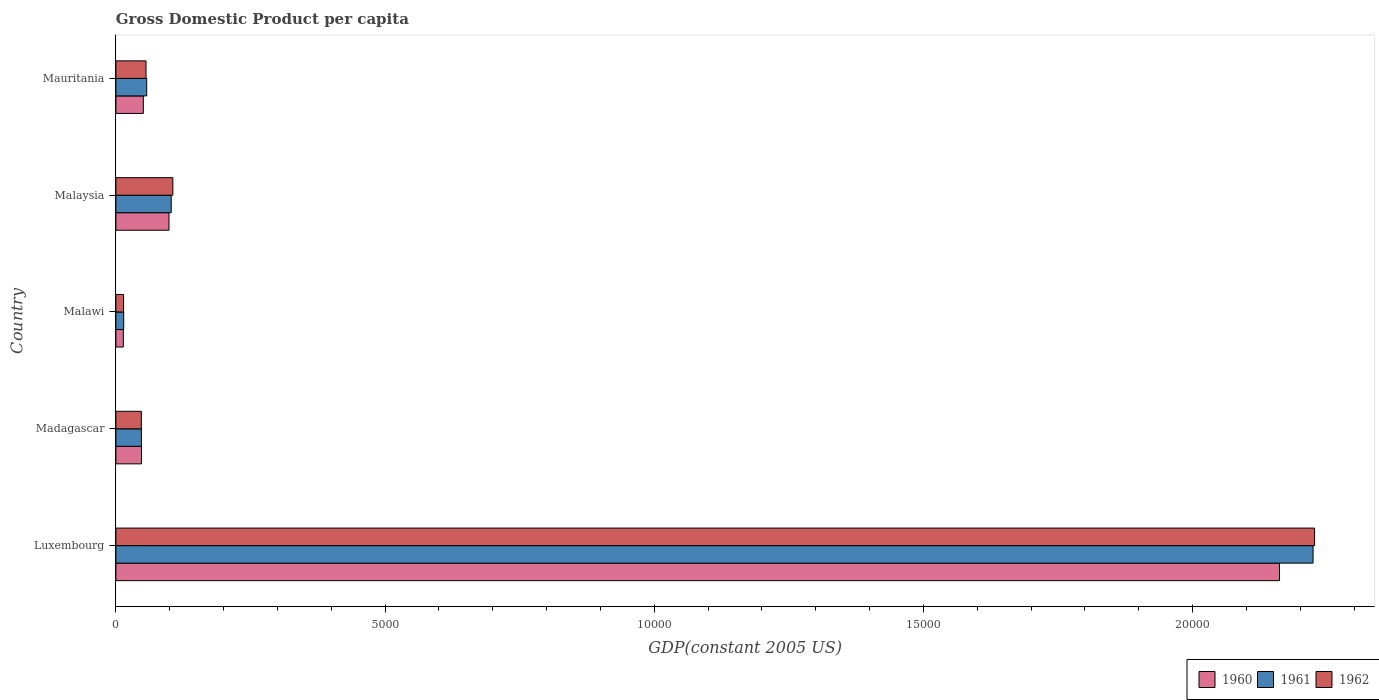Are the number of bars on each tick of the Y-axis equal?
Ensure brevity in your answer.  Yes. How many bars are there on the 2nd tick from the bottom?
Make the answer very short. 3. What is the label of the 3rd group of bars from the top?
Your answer should be compact. Malawi. What is the GDP per capita in 1962 in Mauritania?
Provide a short and direct response. 559.73. Across all countries, what is the maximum GDP per capita in 1962?
Give a very brief answer. 2.23e+04. Across all countries, what is the minimum GDP per capita in 1961?
Your answer should be very brief. 145.39. In which country was the GDP per capita in 1961 maximum?
Provide a succinct answer. Luxembourg. In which country was the GDP per capita in 1961 minimum?
Give a very brief answer. Malawi. What is the total GDP per capita in 1960 in the graph?
Your answer should be compact. 2.37e+04. What is the difference between the GDP per capita in 1960 in Madagascar and that in Malawi?
Offer a terse response. 337.39. What is the difference between the GDP per capita in 1962 in Malaysia and the GDP per capita in 1961 in Luxembourg?
Your answer should be very brief. -2.12e+04. What is the average GDP per capita in 1961 per country?
Offer a terse response. 4891.3. What is the difference between the GDP per capita in 1960 and GDP per capita in 1962 in Malawi?
Make the answer very short. -4.99. In how many countries, is the GDP per capita in 1962 greater than 13000 US$?
Offer a very short reply. 1. What is the ratio of the GDP per capita in 1961 in Luxembourg to that in Madagascar?
Provide a succinct answer. 46.94. Is the difference between the GDP per capita in 1960 in Madagascar and Malawi greater than the difference between the GDP per capita in 1962 in Madagascar and Malawi?
Keep it short and to the point. Yes. What is the difference between the highest and the second highest GDP per capita in 1960?
Offer a very short reply. 2.06e+04. What is the difference between the highest and the lowest GDP per capita in 1962?
Offer a terse response. 2.21e+04. In how many countries, is the GDP per capita in 1960 greater than the average GDP per capita in 1960 taken over all countries?
Ensure brevity in your answer.  1. Is the sum of the GDP per capita in 1961 in Madagascar and Malawi greater than the maximum GDP per capita in 1962 across all countries?
Provide a short and direct response. No. What does the 2nd bar from the bottom in Madagascar represents?
Your answer should be compact. 1961. How many bars are there?
Make the answer very short. 15. Are all the bars in the graph horizontal?
Your answer should be compact. Yes. How many countries are there in the graph?
Your response must be concise. 5. Does the graph contain grids?
Ensure brevity in your answer.  No. Where does the legend appear in the graph?
Give a very brief answer. Bottom right. How many legend labels are there?
Offer a terse response. 3. How are the legend labels stacked?
Offer a very short reply. Horizontal. What is the title of the graph?
Give a very brief answer. Gross Domestic Product per capita. Does "1986" appear as one of the legend labels in the graph?
Keep it short and to the point. No. What is the label or title of the X-axis?
Offer a very short reply. GDP(constant 2005 US). What is the GDP(constant 2005 US) in 1960 in Luxembourg?
Give a very brief answer. 2.16e+04. What is the GDP(constant 2005 US) of 1961 in Luxembourg?
Make the answer very short. 2.22e+04. What is the GDP(constant 2005 US) of 1962 in Luxembourg?
Your response must be concise. 2.23e+04. What is the GDP(constant 2005 US) in 1960 in Madagascar?
Your answer should be compact. 475.5. What is the GDP(constant 2005 US) of 1961 in Madagascar?
Keep it short and to the point. 473.7. What is the GDP(constant 2005 US) of 1962 in Madagascar?
Keep it short and to the point. 472.78. What is the GDP(constant 2005 US) of 1960 in Malawi?
Offer a very short reply. 138.11. What is the GDP(constant 2005 US) of 1961 in Malawi?
Keep it short and to the point. 145.39. What is the GDP(constant 2005 US) in 1962 in Malawi?
Make the answer very short. 143.1. What is the GDP(constant 2005 US) of 1960 in Malaysia?
Offer a very short reply. 986.48. What is the GDP(constant 2005 US) of 1961 in Malaysia?
Your answer should be compact. 1027.64. What is the GDP(constant 2005 US) in 1962 in Malaysia?
Offer a terse response. 1058.31. What is the GDP(constant 2005 US) in 1960 in Mauritania?
Make the answer very short. 509.58. What is the GDP(constant 2005 US) of 1961 in Mauritania?
Keep it short and to the point. 572.02. What is the GDP(constant 2005 US) in 1962 in Mauritania?
Ensure brevity in your answer.  559.73. Across all countries, what is the maximum GDP(constant 2005 US) in 1960?
Make the answer very short. 2.16e+04. Across all countries, what is the maximum GDP(constant 2005 US) in 1961?
Offer a very short reply. 2.22e+04. Across all countries, what is the maximum GDP(constant 2005 US) of 1962?
Provide a short and direct response. 2.23e+04. Across all countries, what is the minimum GDP(constant 2005 US) of 1960?
Offer a very short reply. 138.11. Across all countries, what is the minimum GDP(constant 2005 US) of 1961?
Offer a very short reply. 145.39. Across all countries, what is the minimum GDP(constant 2005 US) in 1962?
Give a very brief answer. 143.1. What is the total GDP(constant 2005 US) in 1960 in the graph?
Offer a terse response. 2.37e+04. What is the total GDP(constant 2005 US) in 1961 in the graph?
Keep it short and to the point. 2.45e+04. What is the total GDP(constant 2005 US) of 1962 in the graph?
Provide a succinct answer. 2.45e+04. What is the difference between the GDP(constant 2005 US) of 1960 in Luxembourg and that in Madagascar?
Your answer should be compact. 2.11e+04. What is the difference between the GDP(constant 2005 US) of 1961 in Luxembourg and that in Madagascar?
Provide a short and direct response. 2.18e+04. What is the difference between the GDP(constant 2005 US) of 1962 in Luxembourg and that in Madagascar?
Make the answer very short. 2.18e+04. What is the difference between the GDP(constant 2005 US) of 1960 in Luxembourg and that in Malawi?
Provide a short and direct response. 2.15e+04. What is the difference between the GDP(constant 2005 US) of 1961 in Luxembourg and that in Malawi?
Provide a short and direct response. 2.21e+04. What is the difference between the GDP(constant 2005 US) of 1962 in Luxembourg and that in Malawi?
Offer a terse response. 2.21e+04. What is the difference between the GDP(constant 2005 US) in 1960 in Luxembourg and that in Malaysia?
Provide a succinct answer. 2.06e+04. What is the difference between the GDP(constant 2005 US) in 1961 in Luxembourg and that in Malaysia?
Your answer should be compact. 2.12e+04. What is the difference between the GDP(constant 2005 US) of 1962 in Luxembourg and that in Malaysia?
Ensure brevity in your answer.  2.12e+04. What is the difference between the GDP(constant 2005 US) in 1960 in Luxembourg and that in Mauritania?
Your response must be concise. 2.11e+04. What is the difference between the GDP(constant 2005 US) of 1961 in Luxembourg and that in Mauritania?
Offer a very short reply. 2.17e+04. What is the difference between the GDP(constant 2005 US) in 1962 in Luxembourg and that in Mauritania?
Make the answer very short. 2.17e+04. What is the difference between the GDP(constant 2005 US) in 1960 in Madagascar and that in Malawi?
Your answer should be very brief. 337.39. What is the difference between the GDP(constant 2005 US) of 1961 in Madagascar and that in Malawi?
Provide a succinct answer. 328.31. What is the difference between the GDP(constant 2005 US) of 1962 in Madagascar and that in Malawi?
Ensure brevity in your answer.  329.68. What is the difference between the GDP(constant 2005 US) in 1960 in Madagascar and that in Malaysia?
Provide a succinct answer. -510.99. What is the difference between the GDP(constant 2005 US) in 1961 in Madagascar and that in Malaysia?
Make the answer very short. -553.94. What is the difference between the GDP(constant 2005 US) of 1962 in Madagascar and that in Malaysia?
Ensure brevity in your answer.  -585.53. What is the difference between the GDP(constant 2005 US) in 1960 in Madagascar and that in Mauritania?
Make the answer very short. -34.08. What is the difference between the GDP(constant 2005 US) in 1961 in Madagascar and that in Mauritania?
Give a very brief answer. -98.32. What is the difference between the GDP(constant 2005 US) in 1962 in Madagascar and that in Mauritania?
Give a very brief answer. -86.95. What is the difference between the GDP(constant 2005 US) of 1960 in Malawi and that in Malaysia?
Give a very brief answer. -848.37. What is the difference between the GDP(constant 2005 US) in 1961 in Malawi and that in Malaysia?
Offer a very short reply. -882.25. What is the difference between the GDP(constant 2005 US) of 1962 in Malawi and that in Malaysia?
Ensure brevity in your answer.  -915.21. What is the difference between the GDP(constant 2005 US) of 1960 in Malawi and that in Mauritania?
Give a very brief answer. -371.47. What is the difference between the GDP(constant 2005 US) of 1961 in Malawi and that in Mauritania?
Your response must be concise. -426.63. What is the difference between the GDP(constant 2005 US) of 1962 in Malawi and that in Mauritania?
Provide a short and direct response. -416.63. What is the difference between the GDP(constant 2005 US) of 1960 in Malaysia and that in Mauritania?
Give a very brief answer. 476.9. What is the difference between the GDP(constant 2005 US) in 1961 in Malaysia and that in Mauritania?
Give a very brief answer. 455.62. What is the difference between the GDP(constant 2005 US) of 1962 in Malaysia and that in Mauritania?
Offer a very short reply. 498.58. What is the difference between the GDP(constant 2005 US) in 1960 in Luxembourg and the GDP(constant 2005 US) in 1961 in Madagascar?
Offer a terse response. 2.11e+04. What is the difference between the GDP(constant 2005 US) in 1960 in Luxembourg and the GDP(constant 2005 US) in 1962 in Madagascar?
Ensure brevity in your answer.  2.11e+04. What is the difference between the GDP(constant 2005 US) of 1961 in Luxembourg and the GDP(constant 2005 US) of 1962 in Madagascar?
Your response must be concise. 2.18e+04. What is the difference between the GDP(constant 2005 US) in 1960 in Luxembourg and the GDP(constant 2005 US) in 1961 in Malawi?
Your response must be concise. 2.15e+04. What is the difference between the GDP(constant 2005 US) of 1960 in Luxembourg and the GDP(constant 2005 US) of 1962 in Malawi?
Offer a terse response. 2.15e+04. What is the difference between the GDP(constant 2005 US) of 1961 in Luxembourg and the GDP(constant 2005 US) of 1962 in Malawi?
Keep it short and to the point. 2.21e+04. What is the difference between the GDP(constant 2005 US) of 1960 in Luxembourg and the GDP(constant 2005 US) of 1961 in Malaysia?
Ensure brevity in your answer.  2.06e+04. What is the difference between the GDP(constant 2005 US) in 1960 in Luxembourg and the GDP(constant 2005 US) in 1962 in Malaysia?
Your answer should be compact. 2.06e+04. What is the difference between the GDP(constant 2005 US) of 1961 in Luxembourg and the GDP(constant 2005 US) of 1962 in Malaysia?
Your answer should be compact. 2.12e+04. What is the difference between the GDP(constant 2005 US) of 1960 in Luxembourg and the GDP(constant 2005 US) of 1961 in Mauritania?
Make the answer very short. 2.10e+04. What is the difference between the GDP(constant 2005 US) in 1960 in Luxembourg and the GDP(constant 2005 US) in 1962 in Mauritania?
Ensure brevity in your answer.  2.11e+04. What is the difference between the GDP(constant 2005 US) in 1961 in Luxembourg and the GDP(constant 2005 US) in 1962 in Mauritania?
Offer a very short reply. 2.17e+04. What is the difference between the GDP(constant 2005 US) in 1960 in Madagascar and the GDP(constant 2005 US) in 1961 in Malawi?
Your response must be concise. 330.11. What is the difference between the GDP(constant 2005 US) of 1960 in Madagascar and the GDP(constant 2005 US) of 1962 in Malawi?
Give a very brief answer. 332.4. What is the difference between the GDP(constant 2005 US) of 1961 in Madagascar and the GDP(constant 2005 US) of 1962 in Malawi?
Your answer should be compact. 330.6. What is the difference between the GDP(constant 2005 US) in 1960 in Madagascar and the GDP(constant 2005 US) in 1961 in Malaysia?
Your answer should be compact. -552.14. What is the difference between the GDP(constant 2005 US) in 1960 in Madagascar and the GDP(constant 2005 US) in 1962 in Malaysia?
Give a very brief answer. -582.81. What is the difference between the GDP(constant 2005 US) of 1961 in Madagascar and the GDP(constant 2005 US) of 1962 in Malaysia?
Offer a very short reply. -584.61. What is the difference between the GDP(constant 2005 US) in 1960 in Madagascar and the GDP(constant 2005 US) in 1961 in Mauritania?
Give a very brief answer. -96.52. What is the difference between the GDP(constant 2005 US) of 1960 in Madagascar and the GDP(constant 2005 US) of 1962 in Mauritania?
Provide a short and direct response. -84.23. What is the difference between the GDP(constant 2005 US) in 1961 in Madagascar and the GDP(constant 2005 US) in 1962 in Mauritania?
Provide a short and direct response. -86.03. What is the difference between the GDP(constant 2005 US) of 1960 in Malawi and the GDP(constant 2005 US) of 1961 in Malaysia?
Ensure brevity in your answer.  -889.53. What is the difference between the GDP(constant 2005 US) in 1960 in Malawi and the GDP(constant 2005 US) in 1962 in Malaysia?
Offer a terse response. -920.2. What is the difference between the GDP(constant 2005 US) of 1961 in Malawi and the GDP(constant 2005 US) of 1962 in Malaysia?
Provide a succinct answer. -912.92. What is the difference between the GDP(constant 2005 US) of 1960 in Malawi and the GDP(constant 2005 US) of 1961 in Mauritania?
Your answer should be very brief. -433.91. What is the difference between the GDP(constant 2005 US) of 1960 in Malawi and the GDP(constant 2005 US) of 1962 in Mauritania?
Your answer should be compact. -421.62. What is the difference between the GDP(constant 2005 US) in 1961 in Malawi and the GDP(constant 2005 US) in 1962 in Mauritania?
Provide a succinct answer. -414.34. What is the difference between the GDP(constant 2005 US) of 1960 in Malaysia and the GDP(constant 2005 US) of 1961 in Mauritania?
Provide a short and direct response. 414.47. What is the difference between the GDP(constant 2005 US) of 1960 in Malaysia and the GDP(constant 2005 US) of 1962 in Mauritania?
Provide a succinct answer. 426.75. What is the difference between the GDP(constant 2005 US) of 1961 in Malaysia and the GDP(constant 2005 US) of 1962 in Mauritania?
Ensure brevity in your answer.  467.91. What is the average GDP(constant 2005 US) in 1960 per country?
Offer a terse response. 4744.65. What is the average GDP(constant 2005 US) of 1961 per country?
Your answer should be compact. 4891.3. What is the average GDP(constant 2005 US) in 1962 per country?
Your response must be concise. 4899.88. What is the difference between the GDP(constant 2005 US) of 1960 and GDP(constant 2005 US) of 1961 in Luxembourg?
Your answer should be compact. -624.17. What is the difference between the GDP(constant 2005 US) in 1960 and GDP(constant 2005 US) in 1962 in Luxembourg?
Your response must be concise. -651.89. What is the difference between the GDP(constant 2005 US) of 1961 and GDP(constant 2005 US) of 1962 in Luxembourg?
Your response must be concise. -27.73. What is the difference between the GDP(constant 2005 US) of 1960 and GDP(constant 2005 US) of 1961 in Madagascar?
Offer a very short reply. 1.8. What is the difference between the GDP(constant 2005 US) in 1960 and GDP(constant 2005 US) in 1962 in Madagascar?
Offer a terse response. 2.72. What is the difference between the GDP(constant 2005 US) in 1961 and GDP(constant 2005 US) in 1962 in Madagascar?
Your answer should be very brief. 0.92. What is the difference between the GDP(constant 2005 US) in 1960 and GDP(constant 2005 US) in 1961 in Malawi?
Your answer should be compact. -7.28. What is the difference between the GDP(constant 2005 US) of 1960 and GDP(constant 2005 US) of 1962 in Malawi?
Ensure brevity in your answer.  -4.99. What is the difference between the GDP(constant 2005 US) in 1961 and GDP(constant 2005 US) in 1962 in Malawi?
Offer a terse response. 2.29. What is the difference between the GDP(constant 2005 US) in 1960 and GDP(constant 2005 US) in 1961 in Malaysia?
Offer a very short reply. -41.16. What is the difference between the GDP(constant 2005 US) of 1960 and GDP(constant 2005 US) of 1962 in Malaysia?
Ensure brevity in your answer.  -71.82. What is the difference between the GDP(constant 2005 US) in 1961 and GDP(constant 2005 US) in 1962 in Malaysia?
Keep it short and to the point. -30.67. What is the difference between the GDP(constant 2005 US) in 1960 and GDP(constant 2005 US) in 1961 in Mauritania?
Provide a short and direct response. -62.44. What is the difference between the GDP(constant 2005 US) in 1960 and GDP(constant 2005 US) in 1962 in Mauritania?
Make the answer very short. -50.15. What is the difference between the GDP(constant 2005 US) of 1961 and GDP(constant 2005 US) of 1962 in Mauritania?
Offer a terse response. 12.29. What is the ratio of the GDP(constant 2005 US) of 1960 in Luxembourg to that in Madagascar?
Offer a terse response. 45.45. What is the ratio of the GDP(constant 2005 US) in 1961 in Luxembourg to that in Madagascar?
Provide a short and direct response. 46.95. What is the ratio of the GDP(constant 2005 US) of 1962 in Luxembourg to that in Madagascar?
Provide a short and direct response. 47.1. What is the ratio of the GDP(constant 2005 US) in 1960 in Luxembourg to that in Malawi?
Your answer should be compact. 156.49. What is the ratio of the GDP(constant 2005 US) in 1961 in Luxembourg to that in Malawi?
Make the answer very short. 152.95. What is the ratio of the GDP(constant 2005 US) of 1962 in Luxembourg to that in Malawi?
Provide a short and direct response. 155.6. What is the ratio of the GDP(constant 2005 US) of 1960 in Luxembourg to that in Malaysia?
Provide a short and direct response. 21.91. What is the ratio of the GDP(constant 2005 US) in 1961 in Luxembourg to that in Malaysia?
Ensure brevity in your answer.  21.64. What is the ratio of the GDP(constant 2005 US) in 1962 in Luxembourg to that in Malaysia?
Provide a short and direct response. 21.04. What is the ratio of the GDP(constant 2005 US) of 1960 in Luxembourg to that in Mauritania?
Offer a terse response. 42.41. What is the ratio of the GDP(constant 2005 US) of 1961 in Luxembourg to that in Mauritania?
Offer a terse response. 38.88. What is the ratio of the GDP(constant 2005 US) of 1962 in Luxembourg to that in Mauritania?
Provide a short and direct response. 39.78. What is the ratio of the GDP(constant 2005 US) in 1960 in Madagascar to that in Malawi?
Your answer should be very brief. 3.44. What is the ratio of the GDP(constant 2005 US) of 1961 in Madagascar to that in Malawi?
Offer a very short reply. 3.26. What is the ratio of the GDP(constant 2005 US) of 1962 in Madagascar to that in Malawi?
Your answer should be compact. 3.3. What is the ratio of the GDP(constant 2005 US) in 1960 in Madagascar to that in Malaysia?
Keep it short and to the point. 0.48. What is the ratio of the GDP(constant 2005 US) of 1961 in Madagascar to that in Malaysia?
Keep it short and to the point. 0.46. What is the ratio of the GDP(constant 2005 US) of 1962 in Madagascar to that in Malaysia?
Your response must be concise. 0.45. What is the ratio of the GDP(constant 2005 US) of 1960 in Madagascar to that in Mauritania?
Your answer should be compact. 0.93. What is the ratio of the GDP(constant 2005 US) of 1961 in Madagascar to that in Mauritania?
Your response must be concise. 0.83. What is the ratio of the GDP(constant 2005 US) of 1962 in Madagascar to that in Mauritania?
Your answer should be very brief. 0.84. What is the ratio of the GDP(constant 2005 US) in 1960 in Malawi to that in Malaysia?
Make the answer very short. 0.14. What is the ratio of the GDP(constant 2005 US) of 1961 in Malawi to that in Malaysia?
Your answer should be very brief. 0.14. What is the ratio of the GDP(constant 2005 US) in 1962 in Malawi to that in Malaysia?
Provide a short and direct response. 0.14. What is the ratio of the GDP(constant 2005 US) of 1960 in Malawi to that in Mauritania?
Keep it short and to the point. 0.27. What is the ratio of the GDP(constant 2005 US) of 1961 in Malawi to that in Mauritania?
Provide a succinct answer. 0.25. What is the ratio of the GDP(constant 2005 US) of 1962 in Malawi to that in Mauritania?
Your answer should be compact. 0.26. What is the ratio of the GDP(constant 2005 US) in 1960 in Malaysia to that in Mauritania?
Make the answer very short. 1.94. What is the ratio of the GDP(constant 2005 US) in 1961 in Malaysia to that in Mauritania?
Your answer should be very brief. 1.8. What is the ratio of the GDP(constant 2005 US) in 1962 in Malaysia to that in Mauritania?
Keep it short and to the point. 1.89. What is the difference between the highest and the second highest GDP(constant 2005 US) in 1960?
Keep it short and to the point. 2.06e+04. What is the difference between the highest and the second highest GDP(constant 2005 US) in 1961?
Offer a very short reply. 2.12e+04. What is the difference between the highest and the second highest GDP(constant 2005 US) in 1962?
Offer a very short reply. 2.12e+04. What is the difference between the highest and the lowest GDP(constant 2005 US) in 1960?
Your answer should be very brief. 2.15e+04. What is the difference between the highest and the lowest GDP(constant 2005 US) in 1961?
Offer a terse response. 2.21e+04. What is the difference between the highest and the lowest GDP(constant 2005 US) in 1962?
Your answer should be very brief. 2.21e+04. 